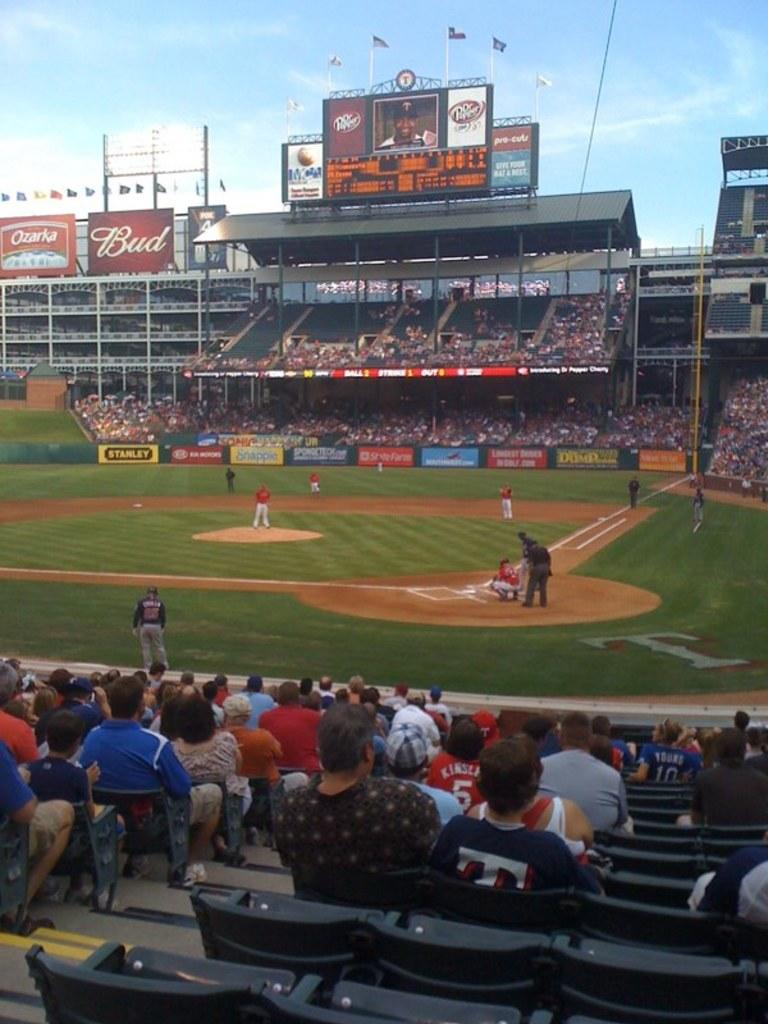<image>
Describe the image concisely. Fans are watching a baseball game in a stadium filled with ads for products like Bud. 